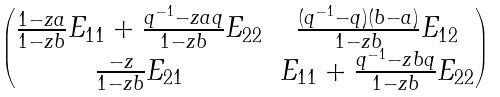<formula> <loc_0><loc_0><loc_500><loc_500>\begin{pmatrix} \frac { 1 - z a } { 1 - z b } E _ { 1 1 } + \frac { q ^ { - 1 } - z a q } { 1 - z b } E _ { 2 2 } & \frac { ( q ^ { - 1 } - q ) ( b - a ) } { 1 - z b } E _ { 1 2 } \\ \frac { - z } { 1 - z b } E _ { 2 1 } & E _ { 1 1 } + \frac { q ^ { - 1 } - z b q } { 1 - z b } E _ { 2 2 } \end{pmatrix}</formula> 